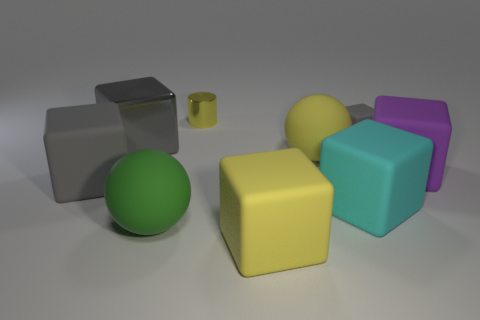Subtract all gray blocks. How many were subtracted if there are1gray blocks left? 2 Subtract all cyan spheres. How many gray blocks are left? 3 Subtract all yellow cubes. How many cubes are left? 5 Subtract all tiny rubber blocks. How many blocks are left? 5 Subtract 1 blocks. How many blocks are left? 5 Subtract all brown spheres. Subtract all brown cylinders. How many spheres are left? 2 Add 1 small cylinders. How many objects exist? 10 Subtract all cylinders. How many objects are left? 8 Subtract all tiny metal objects. Subtract all metal cubes. How many objects are left? 7 Add 3 matte spheres. How many matte spheres are left? 5 